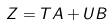Convert formula to latex. <formula><loc_0><loc_0><loc_500><loc_500>Z = T A + U B</formula> 